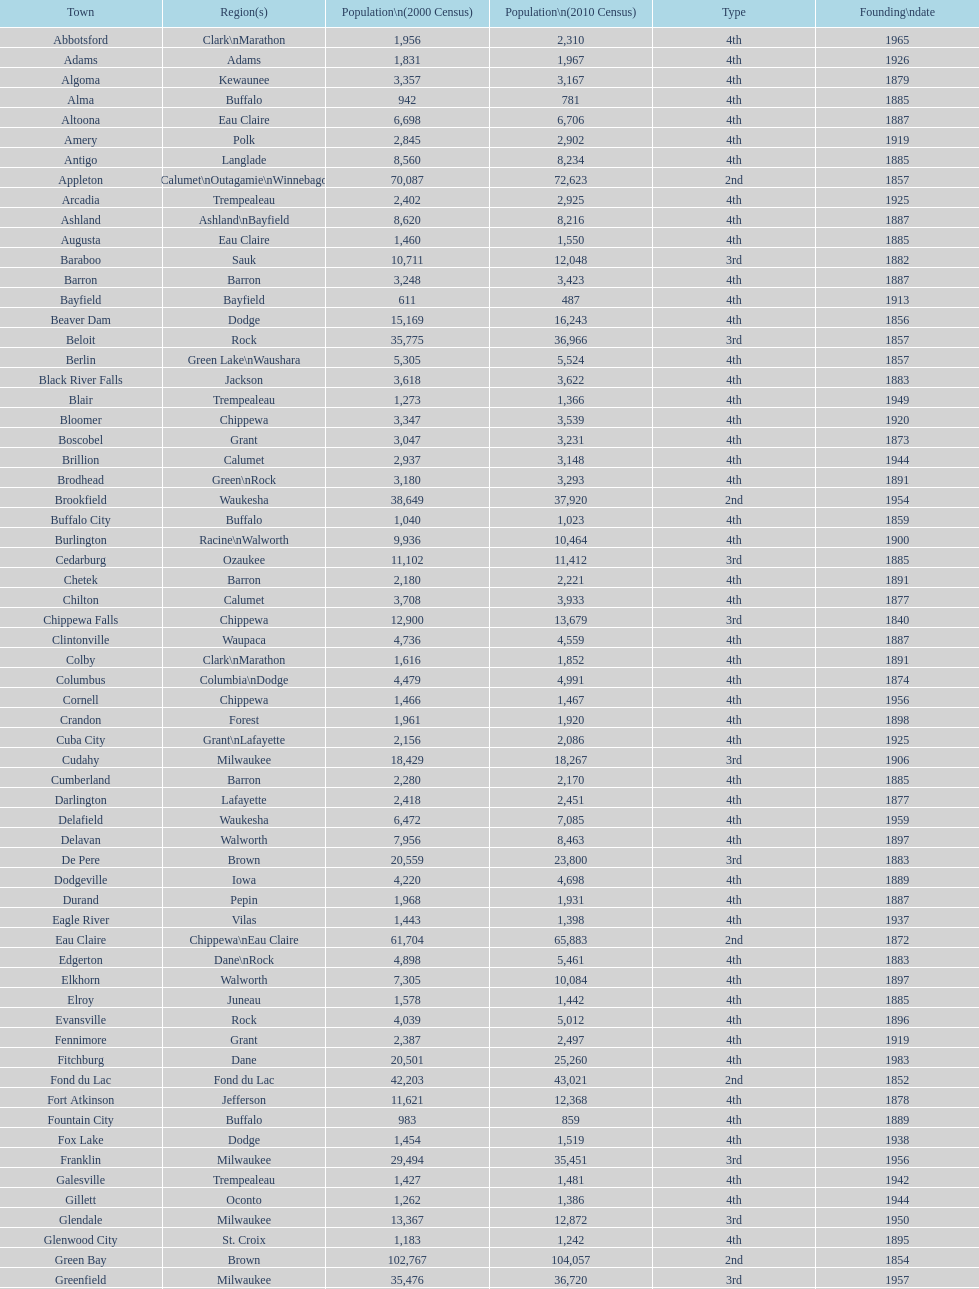How many cities are in wisconsin? 190. 